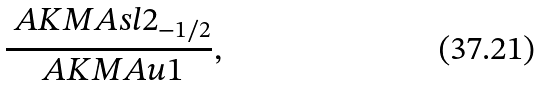<formula> <loc_0><loc_0><loc_500><loc_500>\frac { \ A K M A { s l } { 2 } _ { - 1 / 2 } } { \ A K M A { u } { 1 } } ,</formula> 